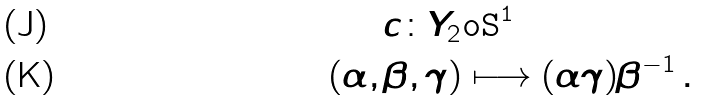Convert formula to latex. <formula><loc_0><loc_0><loc_500><loc_500>c \colon Y _ { 2 } & \tt o S ^ { 1 } \\ ( \alpha , \beta , \gamma ) & \longmapsto ( \alpha \gamma ) \beta ^ { - 1 } \, .</formula> 